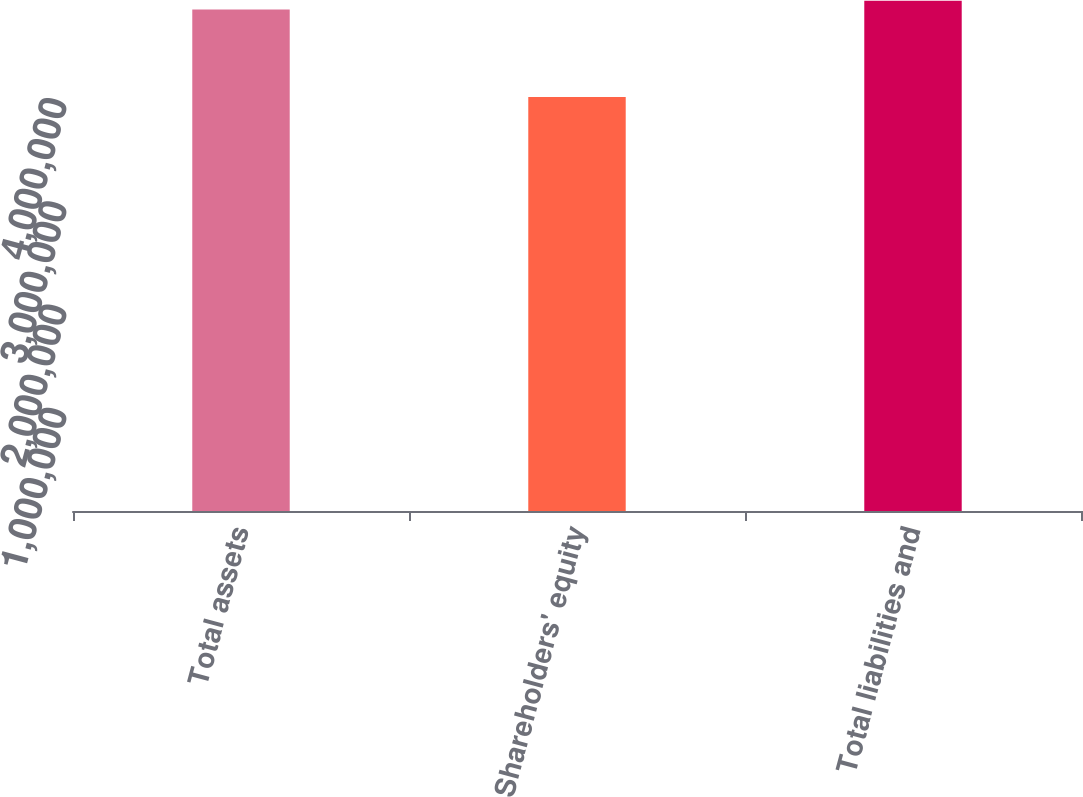Convert chart. <chart><loc_0><loc_0><loc_500><loc_500><bar_chart><fcel>Total assets<fcel>Shareholders' equity<fcel>Total liabilities and<nl><fcel>4.85993e+06<fcel>4.01149e+06<fcel>4.94478e+06<nl></chart> 